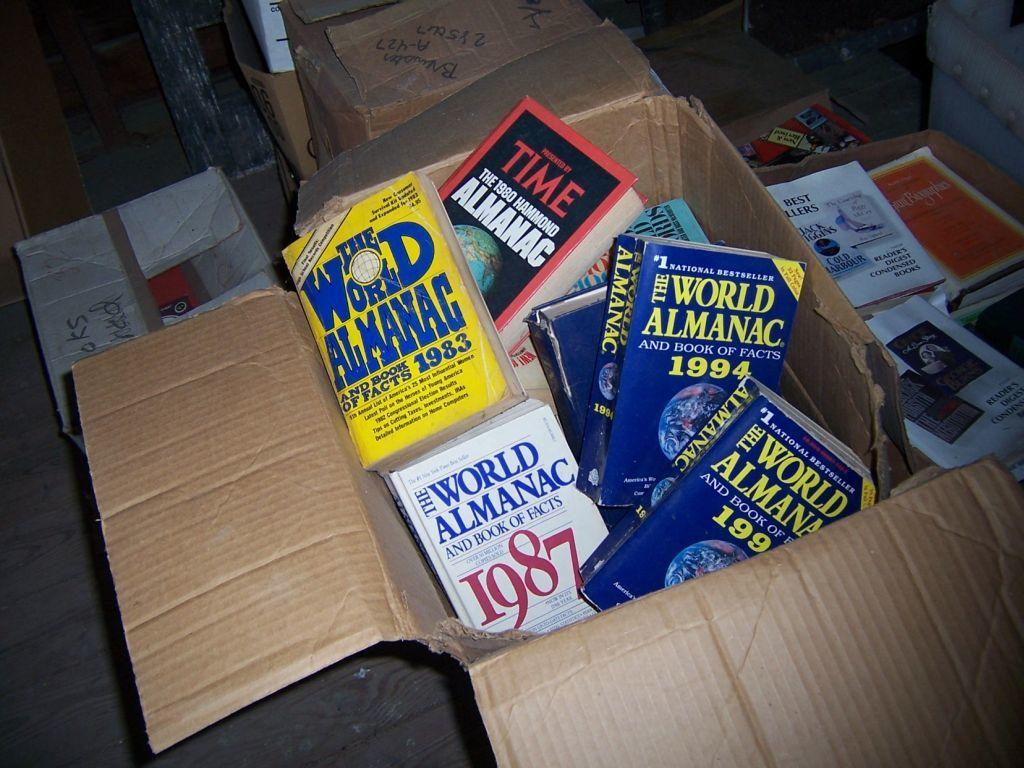<image>
Create a compact narrative representing the image presented. The years 1987 and 1984 are on covers of books in a box. 